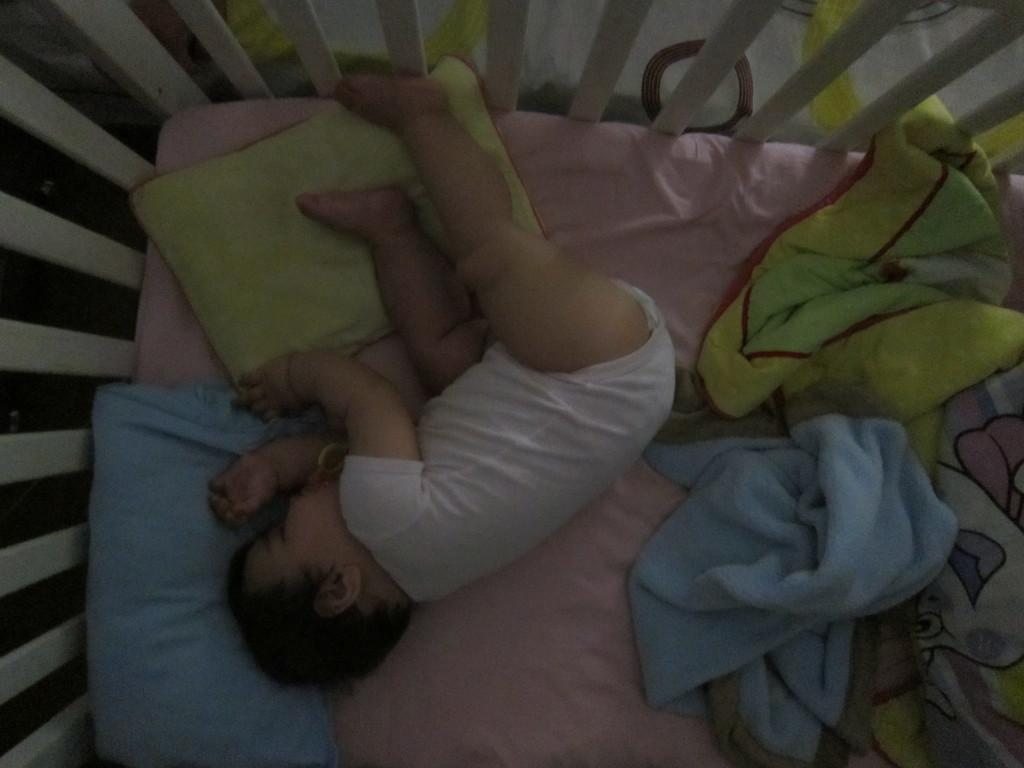What is the main subject of the image? There is a baby in the image. What is the baby doing in the image? The baby is sleeping on the bed. What colors can be seen in the pillows in the image? The pillows in the image have blue and green colors. What colors can be seen in the blankets in the image? The blankets in the image have blue and yellow colors. What type of battle is the baby participating in the image? There is no battle present in the image; the baby is sleeping on the bed. What achievements has the baby accomplished in the image? The baby is sleeping in the image, so there are no achievements to be mentioned. 